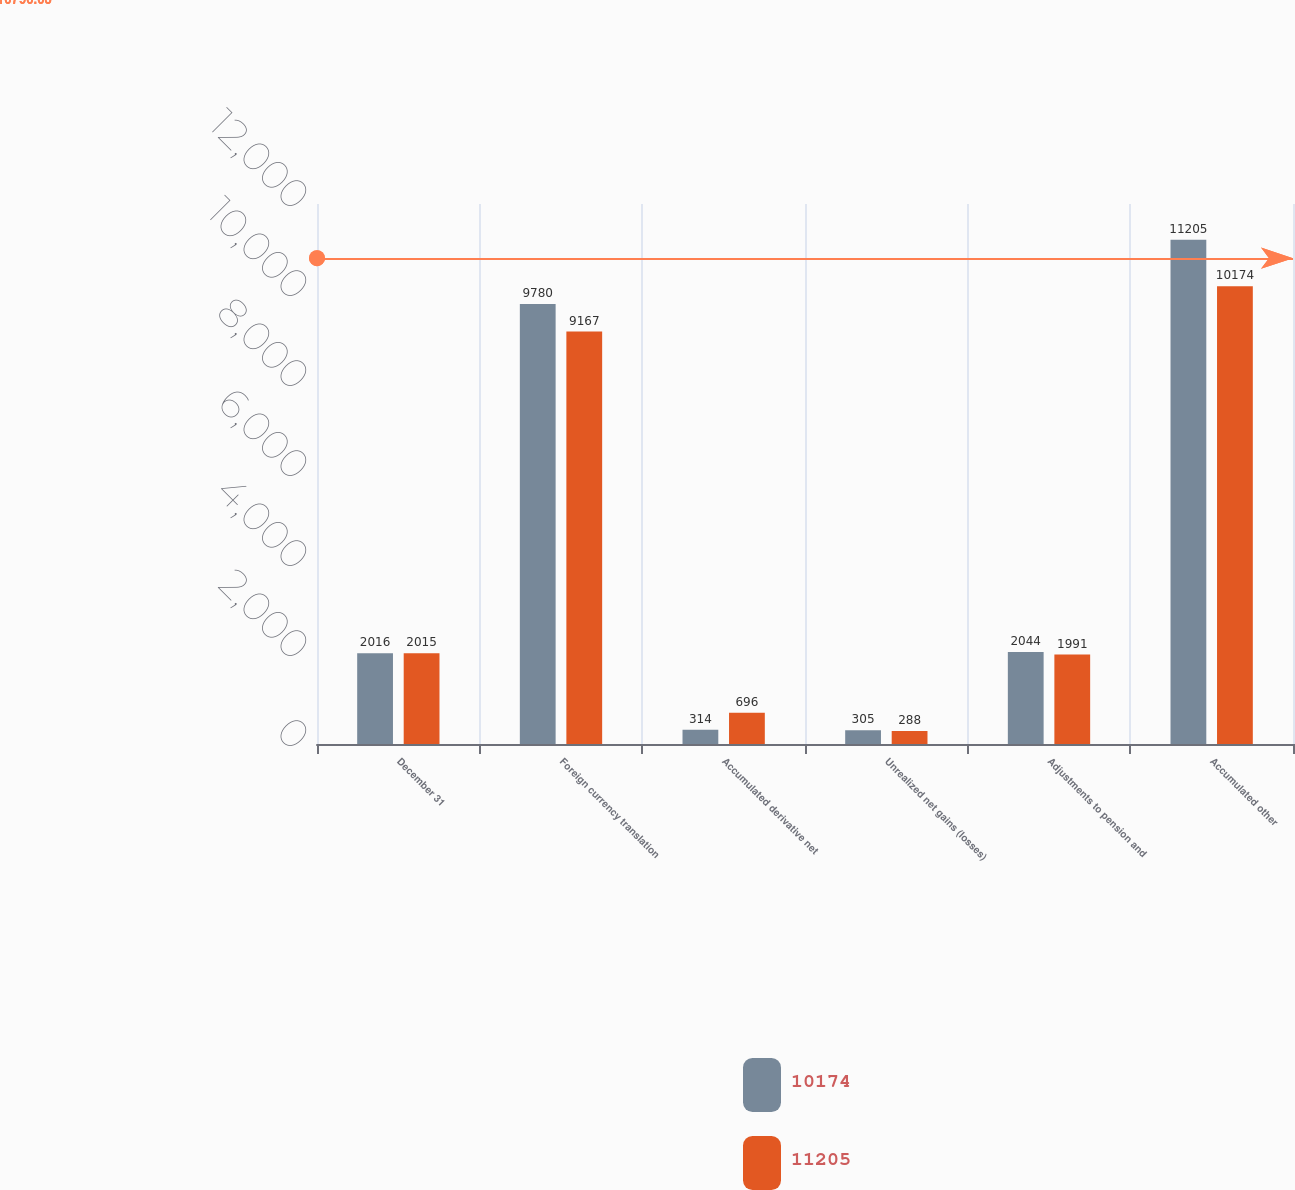Convert chart to OTSL. <chart><loc_0><loc_0><loc_500><loc_500><stacked_bar_chart><ecel><fcel>December 31<fcel>Foreign currency translation<fcel>Accumulated derivative net<fcel>Unrealized net gains (losses)<fcel>Adjustments to pension and<fcel>Accumulated other<nl><fcel>10174<fcel>2016<fcel>9780<fcel>314<fcel>305<fcel>2044<fcel>11205<nl><fcel>11205<fcel>2015<fcel>9167<fcel>696<fcel>288<fcel>1991<fcel>10174<nl></chart> 